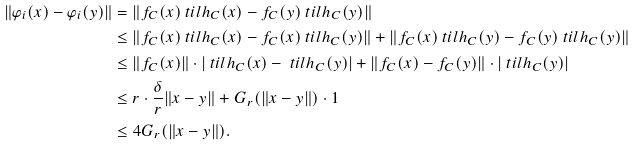Convert formula to latex. <formula><loc_0><loc_0><loc_500><loc_500>\| \varphi _ { i } ( x ) - \varphi _ { i } ( y ) \| & = \| f _ { C } ( x ) \ t i l h _ { C } ( x ) - f _ { C } ( y ) \ t i l h _ { C } ( y ) \| \\ & \leq \| f _ { C } ( x ) \ t i l h _ { C } ( x ) - f _ { C } ( x ) \ t i l h _ { C } ( y ) \| + \| f _ { C } ( x ) \ t i l h _ { C } ( y ) - f _ { C } ( y ) \ t i l h _ { C } ( y ) \| \\ & \leq \| f _ { C } ( x ) \| \cdot | \ t i l h _ { C } ( x ) - \ t i l h _ { C } ( y ) | + \| f _ { C } ( x ) - f _ { C } ( y ) \| \cdot | \ t i l h _ { C } ( y ) | \\ & \leq r \cdot \frac { \delta } { r } \| x - y \| + G _ { r } ( \| x - y \| ) \cdot 1 \\ & \leq 4 G _ { r } ( \| x - y \| ) .</formula> 